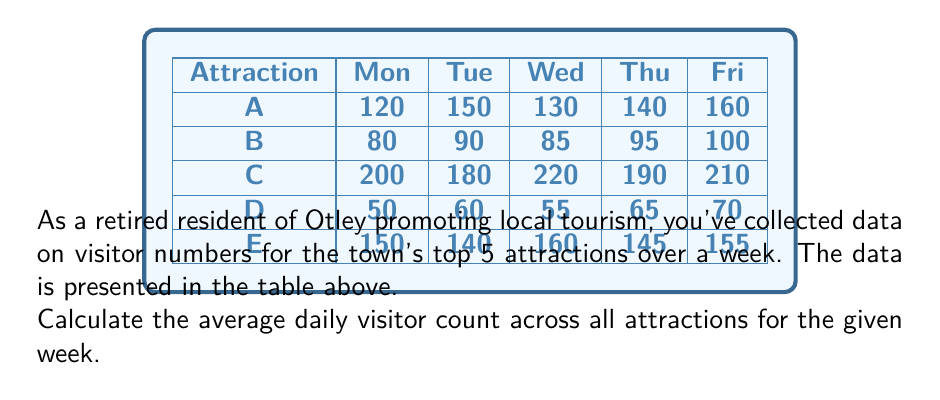Show me your answer to this math problem. To solve this problem, we'll follow these steps:

1) First, let's calculate the total number of visitors for each day:

   Monday: $120 + 80 + 200 + 50 + 150 = 600$
   Tuesday: $150 + 90 + 180 + 60 + 140 = 620$
   Wednesday: $130 + 85 + 220 + 55 + 160 = 650$
   Thursday: $140 + 95 + 190 + 65 + 145 = 635$
   Friday: $160 + 100 + 210 + 70 + 155 = 695$

2) Now, we need to sum up these daily totals:

   $600 + 620 + 650 + 635 + 695 = 3200$

3) To find the average daily visitor count, we divide this total by the number of days (5):

   $$\text{Average} = \frac{\text{Total visitors}}{\text{Number of days}} = \frac{3200}{5} = 640$$

Therefore, the average daily visitor count across all attractions for the given week is 640.
Answer: 640 visitors 